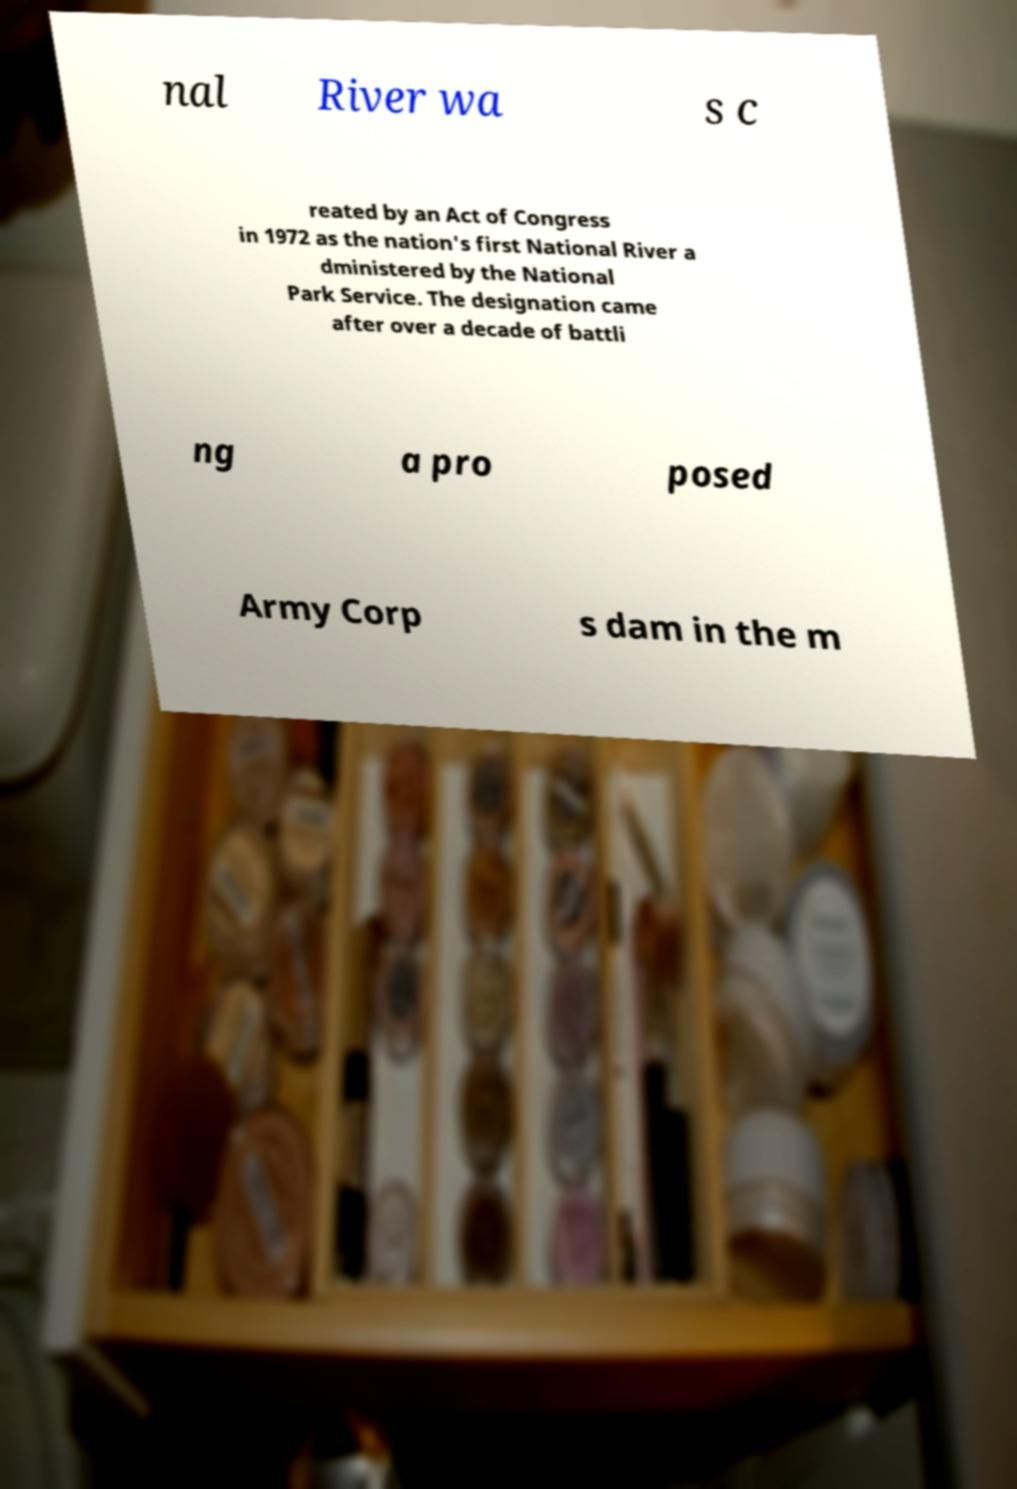What messages or text are displayed in this image? I need them in a readable, typed format. nal River wa s c reated by an Act of Congress in 1972 as the nation's first National River a dministered by the National Park Service. The designation came after over a decade of battli ng a pro posed Army Corp s dam in the m 